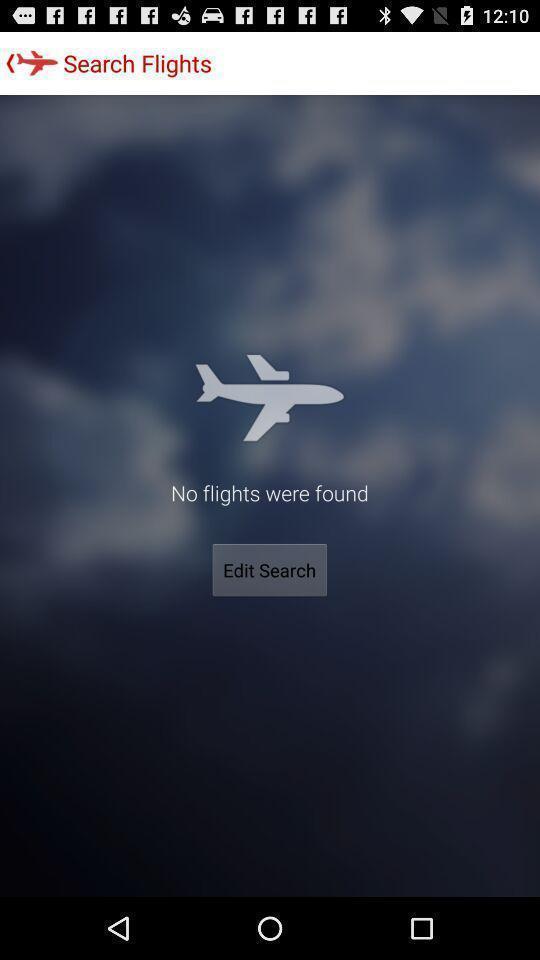Give me a narrative description of this picture. Result page for a flight search in a travel app. 